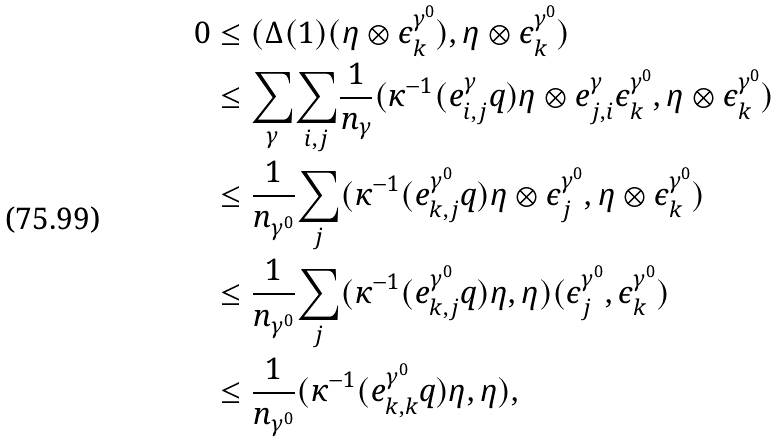<formula> <loc_0><loc_0><loc_500><loc_500>0 & \leq ( \Delta ( 1 ) ( \eta \otimes \epsilon _ { k } ^ { \gamma ^ { 0 } } ) , \eta \otimes \epsilon _ { k } ^ { \gamma ^ { 0 } } ) \\ & \leq \underset { \gamma } { \sum } \underset { i , j } \sum \frac { 1 } { n _ { \gamma } } ( { \kappa ^ { - 1 } ( e ^ { \gamma } _ { i , j } q ) \eta } \otimes e ^ { \gamma } _ { j , i } \epsilon _ { k } ^ { \gamma ^ { 0 } } , \eta \otimes \epsilon _ { k } ^ { \gamma ^ { 0 } } ) \\ & \leq \frac { 1 } { n _ { \gamma ^ { 0 } } } \underset { j } \sum ( { \kappa ^ { - 1 } ( e ^ { \gamma ^ { 0 } } _ { k , j } q ) \eta } \otimes \epsilon _ { j } ^ { \gamma ^ { 0 } } , \eta \otimes \epsilon _ { k } ^ { \gamma ^ { 0 } } ) \\ & \leq \frac { 1 } { n _ { \gamma ^ { 0 } } } \underset { j } \sum ( \kappa ^ { - 1 } ( e ^ { \gamma ^ { 0 } } _ { k , j } q ) \eta , \eta ) ( \epsilon _ { j } ^ { \gamma ^ { 0 } } , \epsilon _ { k } ^ { \gamma ^ { 0 } } ) \\ & \leq \frac { 1 } { n _ { \gamma ^ { 0 } } } ( \kappa ^ { - 1 } ( e ^ { \gamma ^ { 0 } } _ { k , k } q ) \eta , \eta ) ,</formula> 